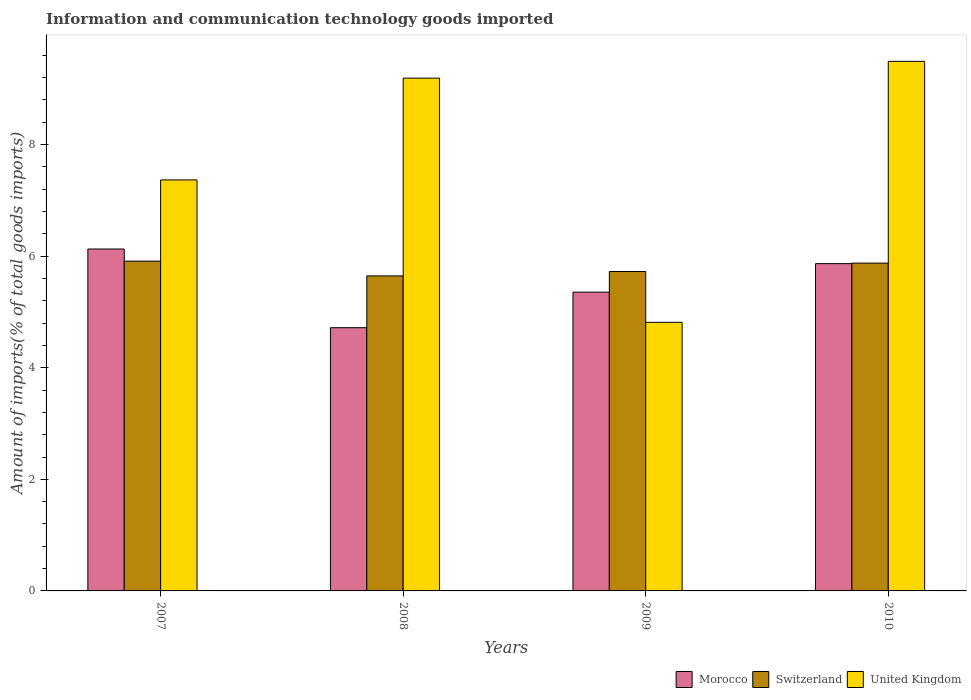How many groups of bars are there?
Your answer should be very brief. 4. Are the number of bars per tick equal to the number of legend labels?
Provide a short and direct response. Yes. How many bars are there on the 3rd tick from the right?
Offer a terse response. 3. In how many cases, is the number of bars for a given year not equal to the number of legend labels?
Keep it short and to the point. 0. What is the amount of goods imported in Morocco in 2010?
Provide a short and direct response. 5.87. Across all years, what is the maximum amount of goods imported in United Kingdom?
Keep it short and to the point. 9.49. Across all years, what is the minimum amount of goods imported in Switzerland?
Provide a succinct answer. 5.65. In which year was the amount of goods imported in United Kingdom maximum?
Your answer should be very brief. 2010. In which year was the amount of goods imported in Switzerland minimum?
Keep it short and to the point. 2008. What is the total amount of goods imported in United Kingdom in the graph?
Offer a very short reply. 30.86. What is the difference between the amount of goods imported in United Kingdom in 2008 and that in 2009?
Provide a succinct answer. 4.38. What is the difference between the amount of goods imported in Switzerland in 2008 and the amount of goods imported in United Kingdom in 2009?
Your answer should be compact. 0.83. What is the average amount of goods imported in Morocco per year?
Make the answer very short. 5.52. In the year 2007, what is the difference between the amount of goods imported in Switzerland and amount of goods imported in Morocco?
Provide a succinct answer. -0.22. What is the ratio of the amount of goods imported in Morocco in 2007 to that in 2008?
Ensure brevity in your answer.  1.3. Is the amount of goods imported in United Kingdom in 2007 less than that in 2009?
Offer a very short reply. No. Is the difference between the amount of goods imported in Switzerland in 2008 and 2009 greater than the difference between the amount of goods imported in Morocco in 2008 and 2009?
Give a very brief answer. Yes. What is the difference between the highest and the second highest amount of goods imported in United Kingdom?
Your answer should be compact. 0.3. What is the difference between the highest and the lowest amount of goods imported in Morocco?
Provide a short and direct response. 1.41. Is the sum of the amount of goods imported in Switzerland in 2007 and 2008 greater than the maximum amount of goods imported in Morocco across all years?
Provide a short and direct response. Yes. What does the 2nd bar from the left in 2009 represents?
Make the answer very short. Switzerland. What does the 2nd bar from the right in 2010 represents?
Your answer should be compact. Switzerland. Is it the case that in every year, the sum of the amount of goods imported in Switzerland and amount of goods imported in United Kingdom is greater than the amount of goods imported in Morocco?
Your answer should be very brief. Yes. How many bars are there?
Provide a succinct answer. 12. How many years are there in the graph?
Give a very brief answer. 4. What is the difference between two consecutive major ticks on the Y-axis?
Your response must be concise. 2. How are the legend labels stacked?
Your response must be concise. Horizontal. What is the title of the graph?
Offer a very short reply. Information and communication technology goods imported. What is the label or title of the Y-axis?
Ensure brevity in your answer.  Amount of imports(% of total goods imports). What is the Amount of imports(% of total goods imports) of Morocco in 2007?
Give a very brief answer. 6.13. What is the Amount of imports(% of total goods imports) of Switzerland in 2007?
Give a very brief answer. 5.91. What is the Amount of imports(% of total goods imports) in United Kingdom in 2007?
Your response must be concise. 7.37. What is the Amount of imports(% of total goods imports) in Morocco in 2008?
Give a very brief answer. 4.72. What is the Amount of imports(% of total goods imports) of Switzerland in 2008?
Give a very brief answer. 5.65. What is the Amount of imports(% of total goods imports) of United Kingdom in 2008?
Your answer should be very brief. 9.19. What is the Amount of imports(% of total goods imports) of Morocco in 2009?
Offer a terse response. 5.36. What is the Amount of imports(% of total goods imports) of Switzerland in 2009?
Your answer should be very brief. 5.73. What is the Amount of imports(% of total goods imports) in United Kingdom in 2009?
Offer a terse response. 4.81. What is the Amount of imports(% of total goods imports) of Morocco in 2010?
Provide a short and direct response. 5.87. What is the Amount of imports(% of total goods imports) in Switzerland in 2010?
Your response must be concise. 5.88. What is the Amount of imports(% of total goods imports) of United Kingdom in 2010?
Make the answer very short. 9.49. Across all years, what is the maximum Amount of imports(% of total goods imports) of Morocco?
Your answer should be compact. 6.13. Across all years, what is the maximum Amount of imports(% of total goods imports) of Switzerland?
Make the answer very short. 5.91. Across all years, what is the maximum Amount of imports(% of total goods imports) in United Kingdom?
Your response must be concise. 9.49. Across all years, what is the minimum Amount of imports(% of total goods imports) of Morocco?
Give a very brief answer. 4.72. Across all years, what is the minimum Amount of imports(% of total goods imports) in Switzerland?
Your answer should be very brief. 5.65. Across all years, what is the minimum Amount of imports(% of total goods imports) in United Kingdom?
Keep it short and to the point. 4.81. What is the total Amount of imports(% of total goods imports) of Morocco in the graph?
Give a very brief answer. 22.07. What is the total Amount of imports(% of total goods imports) in Switzerland in the graph?
Give a very brief answer. 23.16. What is the total Amount of imports(% of total goods imports) of United Kingdom in the graph?
Ensure brevity in your answer.  30.86. What is the difference between the Amount of imports(% of total goods imports) in Morocco in 2007 and that in 2008?
Make the answer very short. 1.41. What is the difference between the Amount of imports(% of total goods imports) of Switzerland in 2007 and that in 2008?
Offer a terse response. 0.27. What is the difference between the Amount of imports(% of total goods imports) of United Kingdom in 2007 and that in 2008?
Provide a succinct answer. -1.82. What is the difference between the Amount of imports(% of total goods imports) in Morocco in 2007 and that in 2009?
Offer a terse response. 0.77. What is the difference between the Amount of imports(% of total goods imports) in Switzerland in 2007 and that in 2009?
Provide a succinct answer. 0.19. What is the difference between the Amount of imports(% of total goods imports) in United Kingdom in 2007 and that in 2009?
Offer a terse response. 2.55. What is the difference between the Amount of imports(% of total goods imports) of Morocco in 2007 and that in 2010?
Your response must be concise. 0.26. What is the difference between the Amount of imports(% of total goods imports) in Switzerland in 2007 and that in 2010?
Give a very brief answer. 0.04. What is the difference between the Amount of imports(% of total goods imports) of United Kingdom in 2007 and that in 2010?
Make the answer very short. -2.13. What is the difference between the Amount of imports(% of total goods imports) of Morocco in 2008 and that in 2009?
Your answer should be compact. -0.64. What is the difference between the Amount of imports(% of total goods imports) in Switzerland in 2008 and that in 2009?
Ensure brevity in your answer.  -0.08. What is the difference between the Amount of imports(% of total goods imports) in United Kingdom in 2008 and that in 2009?
Provide a succinct answer. 4.38. What is the difference between the Amount of imports(% of total goods imports) in Morocco in 2008 and that in 2010?
Offer a terse response. -1.15. What is the difference between the Amount of imports(% of total goods imports) of Switzerland in 2008 and that in 2010?
Ensure brevity in your answer.  -0.23. What is the difference between the Amount of imports(% of total goods imports) in United Kingdom in 2008 and that in 2010?
Provide a succinct answer. -0.3. What is the difference between the Amount of imports(% of total goods imports) of Morocco in 2009 and that in 2010?
Keep it short and to the point. -0.51. What is the difference between the Amount of imports(% of total goods imports) of Switzerland in 2009 and that in 2010?
Offer a terse response. -0.15. What is the difference between the Amount of imports(% of total goods imports) of United Kingdom in 2009 and that in 2010?
Offer a very short reply. -4.68. What is the difference between the Amount of imports(% of total goods imports) of Morocco in 2007 and the Amount of imports(% of total goods imports) of Switzerland in 2008?
Offer a terse response. 0.48. What is the difference between the Amount of imports(% of total goods imports) of Morocco in 2007 and the Amount of imports(% of total goods imports) of United Kingdom in 2008?
Make the answer very short. -3.06. What is the difference between the Amount of imports(% of total goods imports) of Switzerland in 2007 and the Amount of imports(% of total goods imports) of United Kingdom in 2008?
Offer a very short reply. -3.28. What is the difference between the Amount of imports(% of total goods imports) in Morocco in 2007 and the Amount of imports(% of total goods imports) in Switzerland in 2009?
Ensure brevity in your answer.  0.4. What is the difference between the Amount of imports(% of total goods imports) of Morocco in 2007 and the Amount of imports(% of total goods imports) of United Kingdom in 2009?
Make the answer very short. 1.31. What is the difference between the Amount of imports(% of total goods imports) in Switzerland in 2007 and the Amount of imports(% of total goods imports) in United Kingdom in 2009?
Make the answer very short. 1.1. What is the difference between the Amount of imports(% of total goods imports) in Morocco in 2007 and the Amount of imports(% of total goods imports) in Switzerland in 2010?
Offer a terse response. 0.25. What is the difference between the Amount of imports(% of total goods imports) of Morocco in 2007 and the Amount of imports(% of total goods imports) of United Kingdom in 2010?
Keep it short and to the point. -3.36. What is the difference between the Amount of imports(% of total goods imports) in Switzerland in 2007 and the Amount of imports(% of total goods imports) in United Kingdom in 2010?
Offer a very short reply. -3.58. What is the difference between the Amount of imports(% of total goods imports) in Morocco in 2008 and the Amount of imports(% of total goods imports) in Switzerland in 2009?
Your answer should be compact. -1.01. What is the difference between the Amount of imports(% of total goods imports) in Morocco in 2008 and the Amount of imports(% of total goods imports) in United Kingdom in 2009?
Keep it short and to the point. -0.1. What is the difference between the Amount of imports(% of total goods imports) in Switzerland in 2008 and the Amount of imports(% of total goods imports) in United Kingdom in 2009?
Make the answer very short. 0.83. What is the difference between the Amount of imports(% of total goods imports) in Morocco in 2008 and the Amount of imports(% of total goods imports) in Switzerland in 2010?
Your answer should be compact. -1.16. What is the difference between the Amount of imports(% of total goods imports) in Morocco in 2008 and the Amount of imports(% of total goods imports) in United Kingdom in 2010?
Ensure brevity in your answer.  -4.77. What is the difference between the Amount of imports(% of total goods imports) of Switzerland in 2008 and the Amount of imports(% of total goods imports) of United Kingdom in 2010?
Ensure brevity in your answer.  -3.85. What is the difference between the Amount of imports(% of total goods imports) in Morocco in 2009 and the Amount of imports(% of total goods imports) in Switzerland in 2010?
Provide a short and direct response. -0.52. What is the difference between the Amount of imports(% of total goods imports) of Morocco in 2009 and the Amount of imports(% of total goods imports) of United Kingdom in 2010?
Ensure brevity in your answer.  -4.14. What is the difference between the Amount of imports(% of total goods imports) in Switzerland in 2009 and the Amount of imports(% of total goods imports) in United Kingdom in 2010?
Keep it short and to the point. -3.77. What is the average Amount of imports(% of total goods imports) of Morocco per year?
Your answer should be compact. 5.52. What is the average Amount of imports(% of total goods imports) in Switzerland per year?
Keep it short and to the point. 5.79. What is the average Amount of imports(% of total goods imports) in United Kingdom per year?
Your answer should be very brief. 7.72. In the year 2007, what is the difference between the Amount of imports(% of total goods imports) in Morocco and Amount of imports(% of total goods imports) in Switzerland?
Keep it short and to the point. 0.22. In the year 2007, what is the difference between the Amount of imports(% of total goods imports) in Morocco and Amount of imports(% of total goods imports) in United Kingdom?
Provide a succinct answer. -1.24. In the year 2007, what is the difference between the Amount of imports(% of total goods imports) of Switzerland and Amount of imports(% of total goods imports) of United Kingdom?
Ensure brevity in your answer.  -1.46. In the year 2008, what is the difference between the Amount of imports(% of total goods imports) of Morocco and Amount of imports(% of total goods imports) of Switzerland?
Offer a very short reply. -0.93. In the year 2008, what is the difference between the Amount of imports(% of total goods imports) of Morocco and Amount of imports(% of total goods imports) of United Kingdom?
Your answer should be compact. -4.47. In the year 2008, what is the difference between the Amount of imports(% of total goods imports) in Switzerland and Amount of imports(% of total goods imports) in United Kingdom?
Provide a succinct answer. -3.54. In the year 2009, what is the difference between the Amount of imports(% of total goods imports) of Morocco and Amount of imports(% of total goods imports) of Switzerland?
Offer a terse response. -0.37. In the year 2009, what is the difference between the Amount of imports(% of total goods imports) in Morocco and Amount of imports(% of total goods imports) in United Kingdom?
Keep it short and to the point. 0.54. In the year 2009, what is the difference between the Amount of imports(% of total goods imports) in Switzerland and Amount of imports(% of total goods imports) in United Kingdom?
Give a very brief answer. 0.91. In the year 2010, what is the difference between the Amount of imports(% of total goods imports) of Morocco and Amount of imports(% of total goods imports) of Switzerland?
Provide a short and direct response. -0.01. In the year 2010, what is the difference between the Amount of imports(% of total goods imports) of Morocco and Amount of imports(% of total goods imports) of United Kingdom?
Your response must be concise. -3.63. In the year 2010, what is the difference between the Amount of imports(% of total goods imports) of Switzerland and Amount of imports(% of total goods imports) of United Kingdom?
Provide a short and direct response. -3.62. What is the ratio of the Amount of imports(% of total goods imports) of Morocco in 2007 to that in 2008?
Ensure brevity in your answer.  1.3. What is the ratio of the Amount of imports(% of total goods imports) in Switzerland in 2007 to that in 2008?
Give a very brief answer. 1.05. What is the ratio of the Amount of imports(% of total goods imports) of United Kingdom in 2007 to that in 2008?
Your response must be concise. 0.8. What is the ratio of the Amount of imports(% of total goods imports) in Morocco in 2007 to that in 2009?
Offer a very short reply. 1.14. What is the ratio of the Amount of imports(% of total goods imports) in Switzerland in 2007 to that in 2009?
Your response must be concise. 1.03. What is the ratio of the Amount of imports(% of total goods imports) in United Kingdom in 2007 to that in 2009?
Provide a succinct answer. 1.53. What is the ratio of the Amount of imports(% of total goods imports) in Morocco in 2007 to that in 2010?
Your answer should be compact. 1.04. What is the ratio of the Amount of imports(% of total goods imports) of Switzerland in 2007 to that in 2010?
Provide a succinct answer. 1.01. What is the ratio of the Amount of imports(% of total goods imports) of United Kingdom in 2007 to that in 2010?
Your answer should be compact. 0.78. What is the ratio of the Amount of imports(% of total goods imports) in Morocco in 2008 to that in 2009?
Ensure brevity in your answer.  0.88. What is the ratio of the Amount of imports(% of total goods imports) of Switzerland in 2008 to that in 2009?
Provide a succinct answer. 0.99. What is the ratio of the Amount of imports(% of total goods imports) of United Kingdom in 2008 to that in 2009?
Offer a terse response. 1.91. What is the ratio of the Amount of imports(% of total goods imports) in Morocco in 2008 to that in 2010?
Your response must be concise. 0.8. What is the ratio of the Amount of imports(% of total goods imports) in Switzerland in 2008 to that in 2010?
Provide a short and direct response. 0.96. What is the ratio of the Amount of imports(% of total goods imports) of United Kingdom in 2008 to that in 2010?
Provide a short and direct response. 0.97. What is the ratio of the Amount of imports(% of total goods imports) in Morocco in 2009 to that in 2010?
Provide a short and direct response. 0.91. What is the ratio of the Amount of imports(% of total goods imports) in Switzerland in 2009 to that in 2010?
Provide a succinct answer. 0.97. What is the ratio of the Amount of imports(% of total goods imports) of United Kingdom in 2009 to that in 2010?
Your answer should be very brief. 0.51. What is the difference between the highest and the second highest Amount of imports(% of total goods imports) of Morocco?
Offer a very short reply. 0.26. What is the difference between the highest and the second highest Amount of imports(% of total goods imports) in Switzerland?
Offer a very short reply. 0.04. What is the difference between the highest and the second highest Amount of imports(% of total goods imports) in United Kingdom?
Offer a very short reply. 0.3. What is the difference between the highest and the lowest Amount of imports(% of total goods imports) of Morocco?
Keep it short and to the point. 1.41. What is the difference between the highest and the lowest Amount of imports(% of total goods imports) in Switzerland?
Ensure brevity in your answer.  0.27. What is the difference between the highest and the lowest Amount of imports(% of total goods imports) in United Kingdom?
Give a very brief answer. 4.68. 